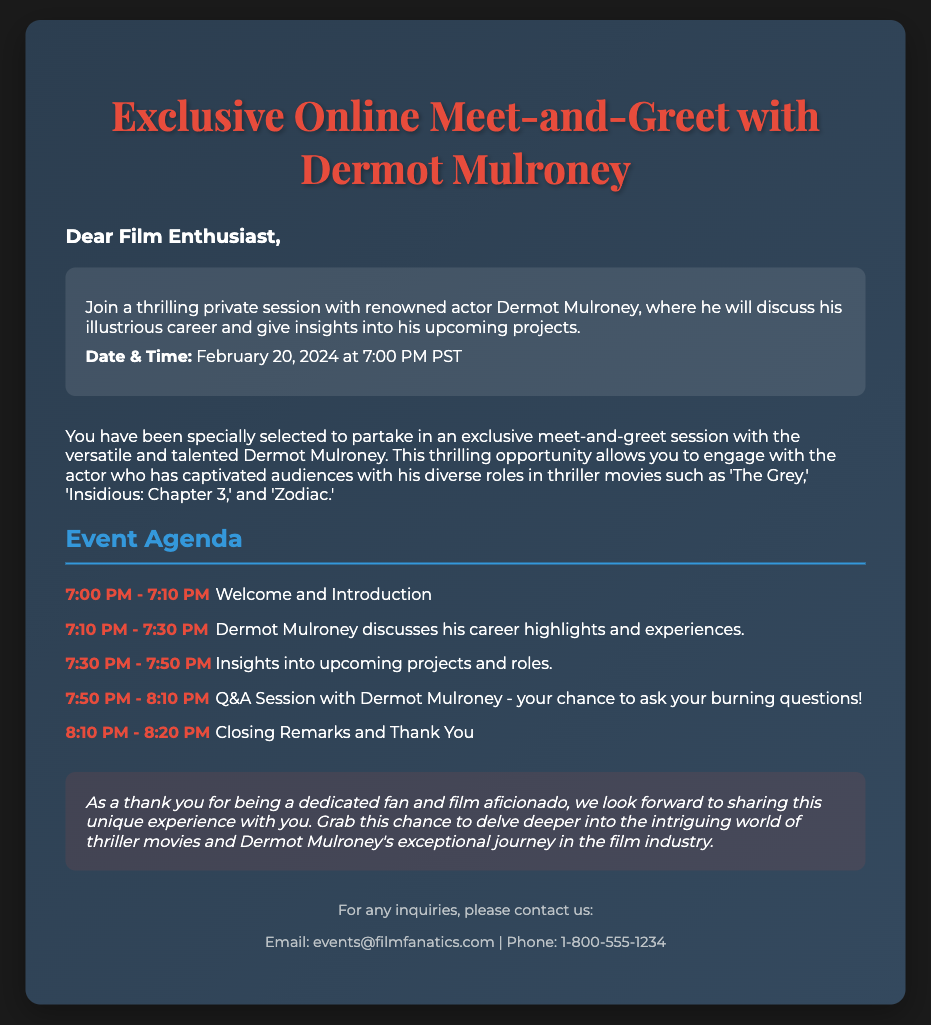What is the date of the meet-and-greet session? The date of the meet-and-greet session is explicitly mentioned in the event details.
Answer: February 20, 2024 What time does the session start? The time the session begins is stated alongside the date in the event details.
Answer: 7:00 PM PST Who is the actor participating in the meet-and-greet? The document specifically names the actor involved in the session.
Answer: Dermot Mulroney What type of films is Dermot Mulroney known for? The document mentions specific genres of movies he is known for, particularly in the context of his career.
Answer: Thriller How long is the Q&A session scheduled for? The duration of the Q&A session is calculated from the agenda details provided in the document.
Answer: 20 minutes What is the email address for inquiries? The document includes a contact information section providing specific details for reaching out.
Answer: events@filmfanatics.com What is the final time listed in the agenda? The last item in the agenda reveals the closing time for the event.
Answer: 8:20 PM What is the purpose of this meet-and-greet? The document explains the objective of the gathering in relation to the actor's career and upcoming roles.
Answer: Discuss his career and upcoming projects 